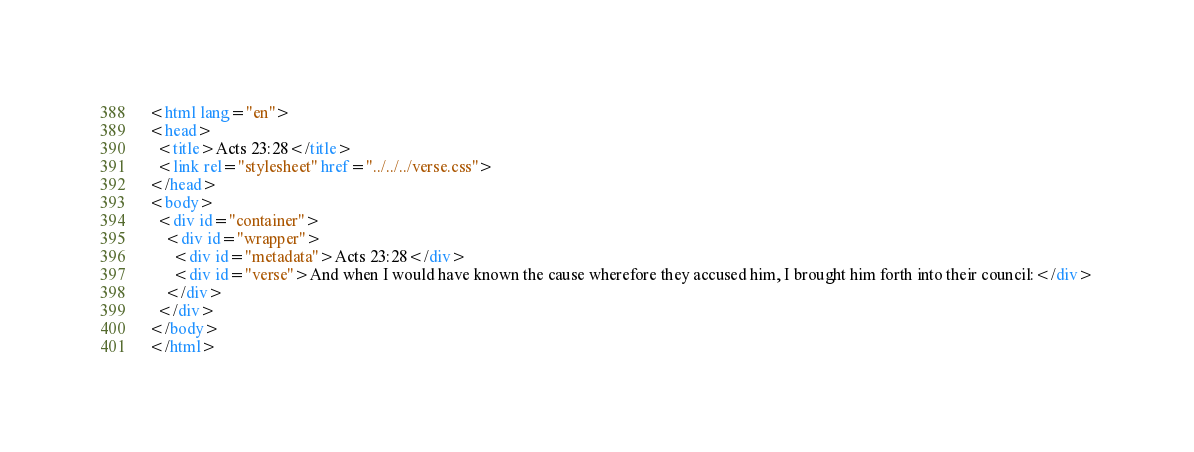<code> <loc_0><loc_0><loc_500><loc_500><_HTML_><html lang="en">
<head>
  <title>Acts 23:28</title>
  <link rel="stylesheet" href="../../../verse.css">
</head>
<body>
  <div id="container">
    <div id="wrapper">
      <div id="metadata">Acts 23:28</div>
      <div id="verse">And when I would have known the cause wherefore they accused him, I brought him forth into their council:</div>
    </div>
  </div>
</body>
</html></code> 